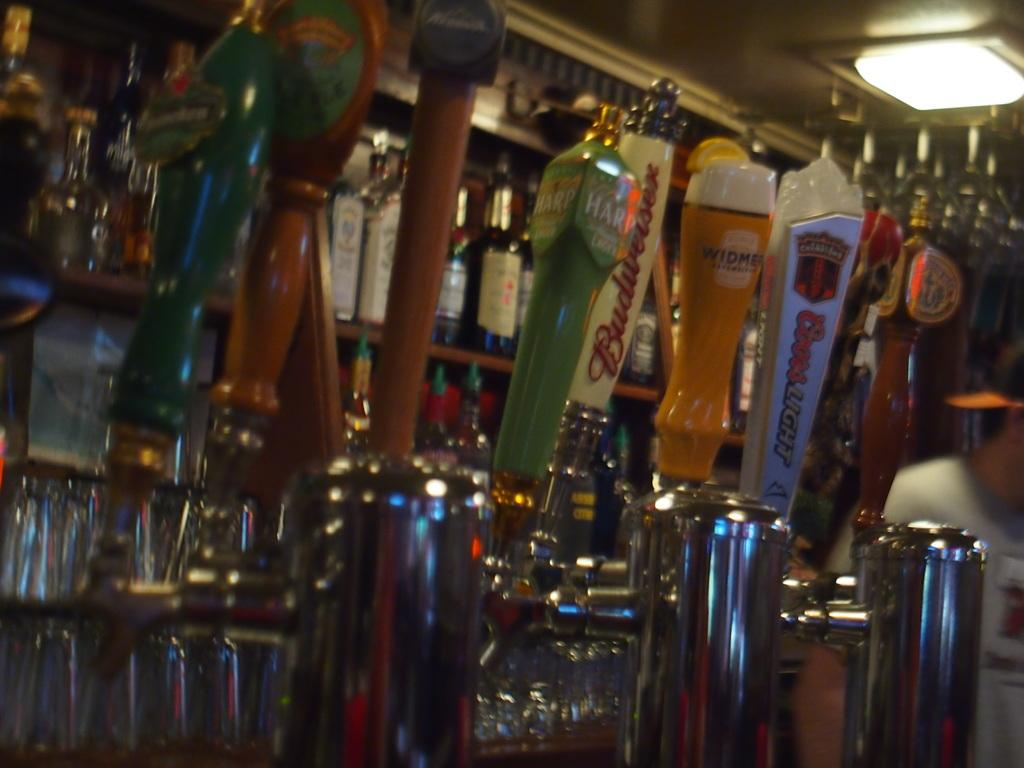Provide a one-sentence caption for the provided image. A series of bar beer taps including Budweiser. 